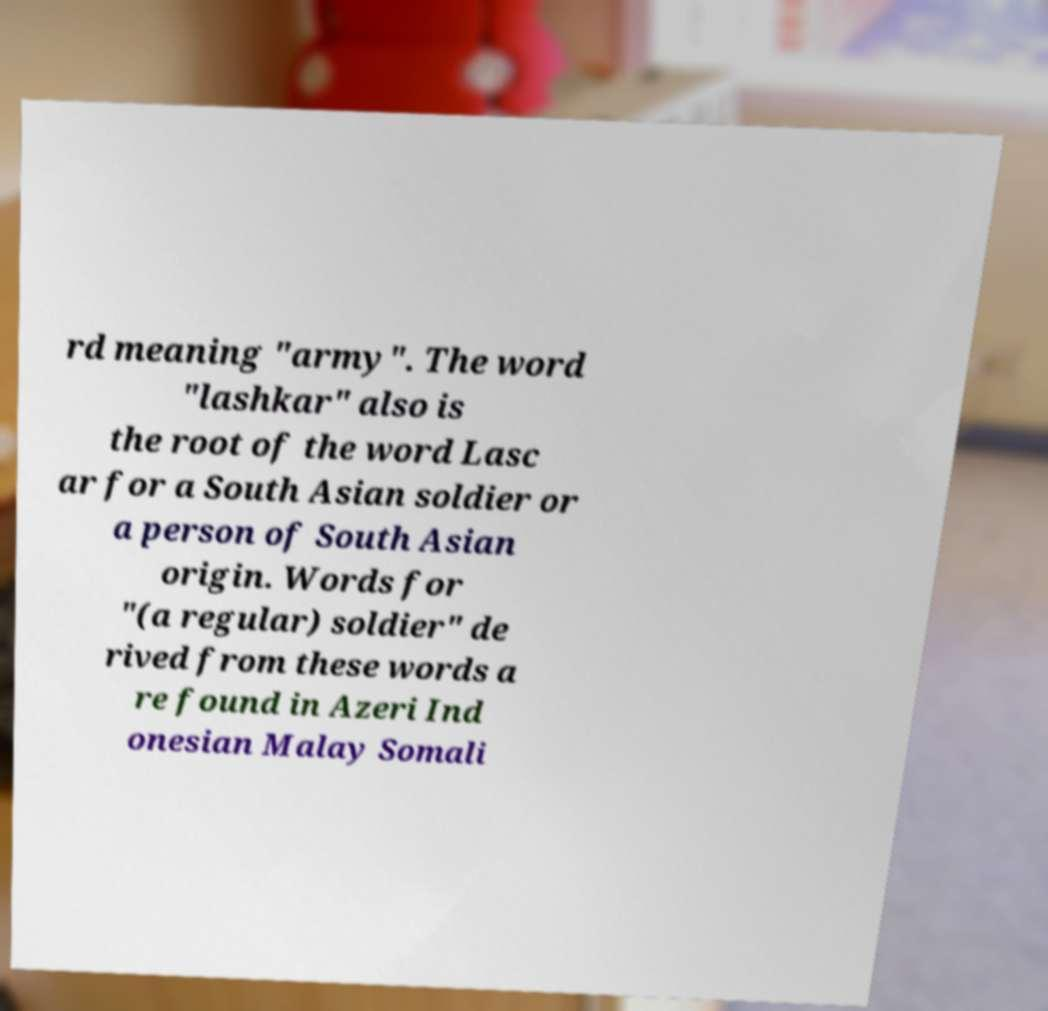There's text embedded in this image that I need extracted. Can you transcribe it verbatim? rd meaning "army". The word "lashkar" also is the root of the word Lasc ar for a South Asian soldier or a person of South Asian origin. Words for "(a regular) soldier" de rived from these words a re found in Azeri Ind onesian Malay Somali 